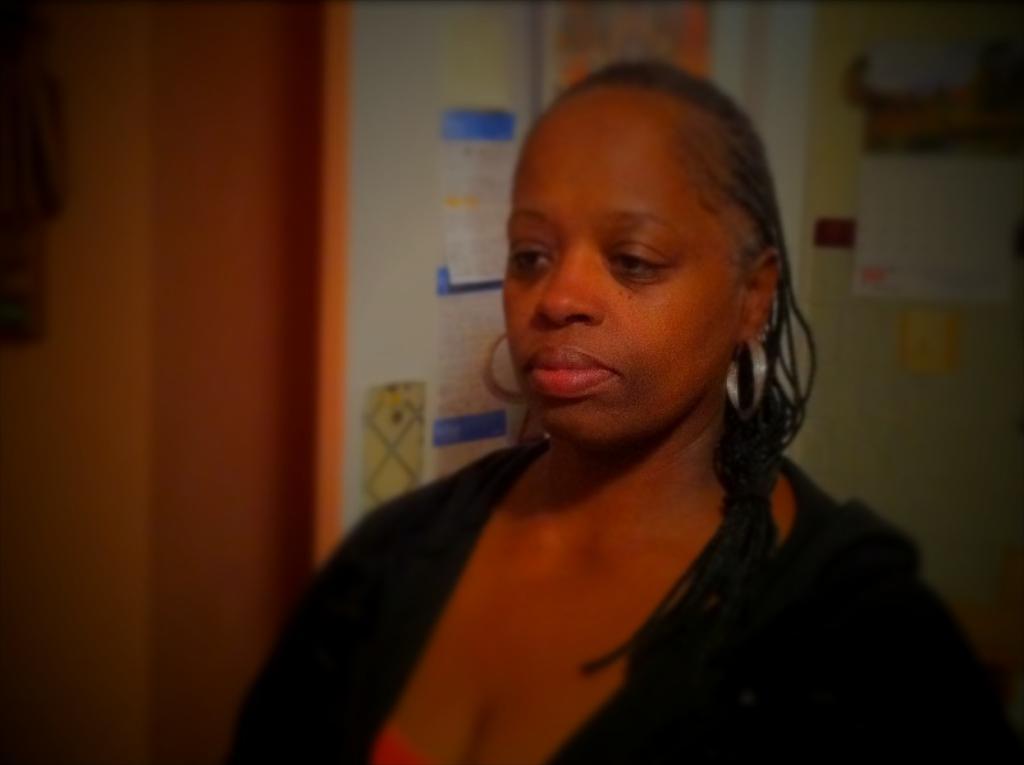Describe this image in one or two sentences. In this image there is a woman, and in the background there are papers stick to the wall. 